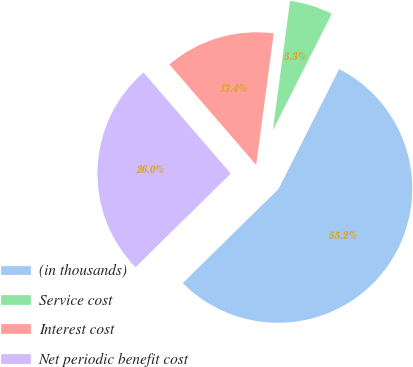Convert chart to OTSL. <chart><loc_0><loc_0><loc_500><loc_500><pie_chart><fcel>(in thousands)<fcel>Service cost<fcel>Interest cost<fcel>Net periodic benefit cost<nl><fcel>55.18%<fcel>5.35%<fcel>13.44%<fcel>26.03%<nl></chart> 